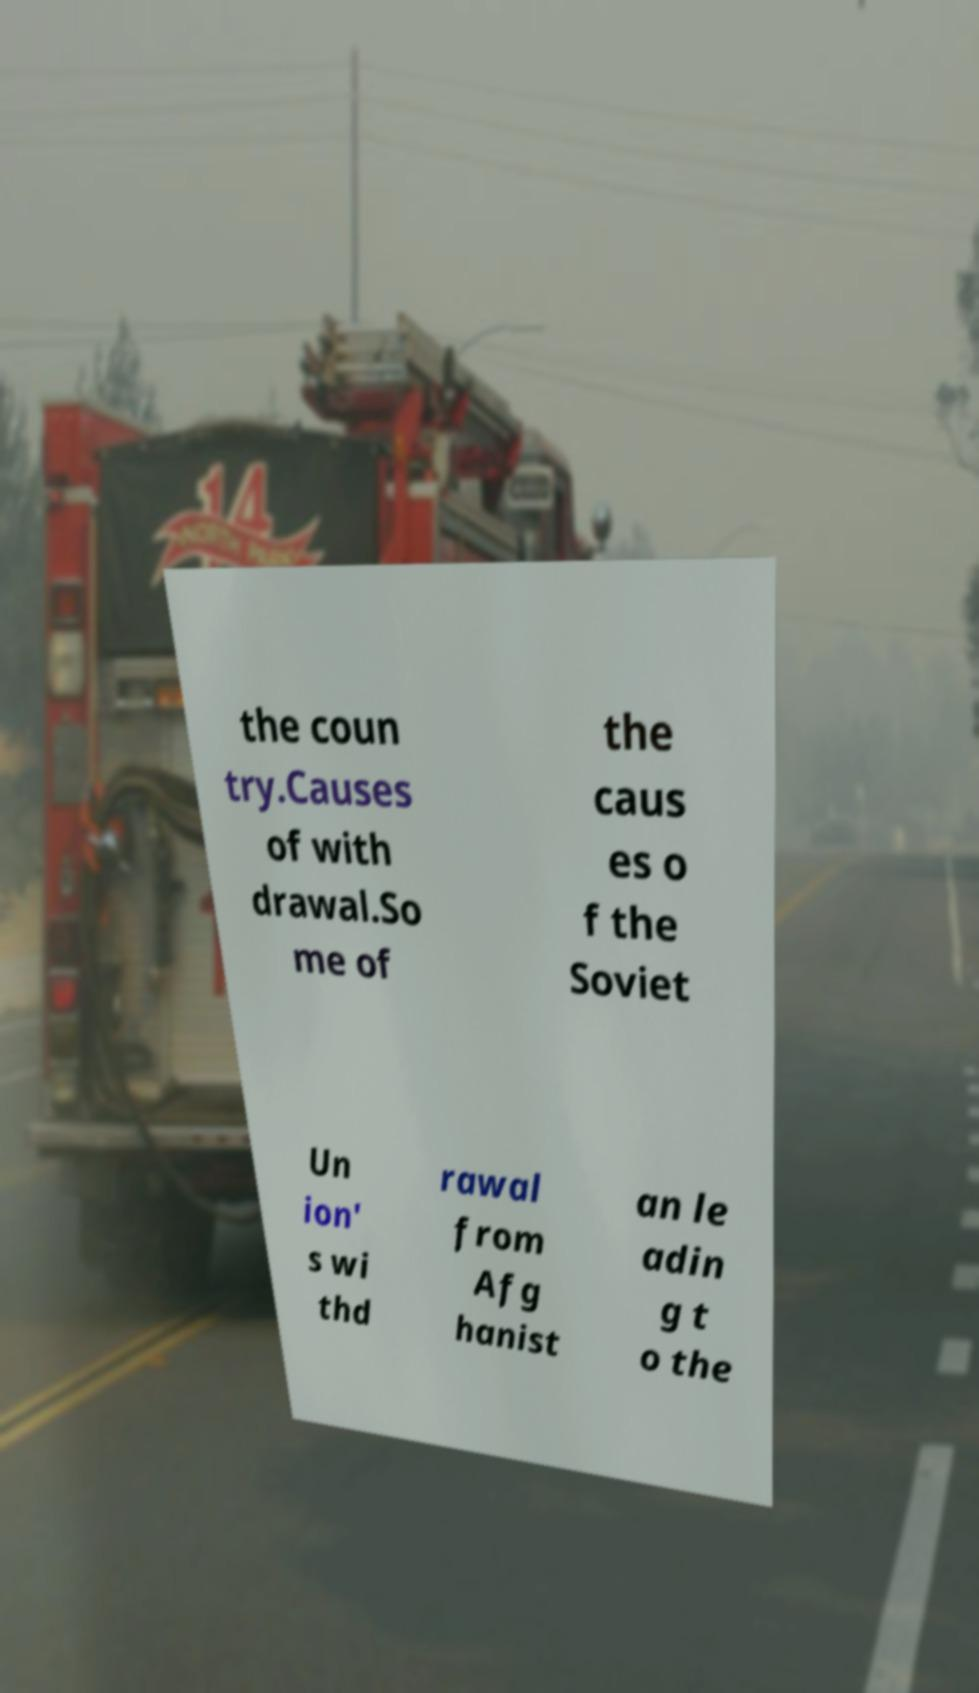Can you accurately transcribe the text from the provided image for me? the coun try.Causes of with drawal.So me of the caus es o f the Soviet Un ion' s wi thd rawal from Afg hanist an le adin g t o the 